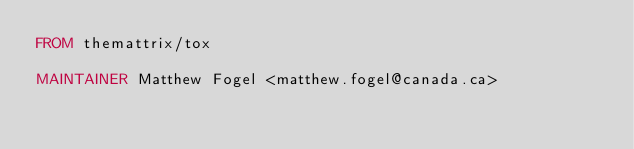<code> <loc_0><loc_0><loc_500><loc_500><_Dockerfile_>FROM themattrix/tox

MAINTAINER Matthew Fogel <matthew.fogel@canada.ca>
</code> 